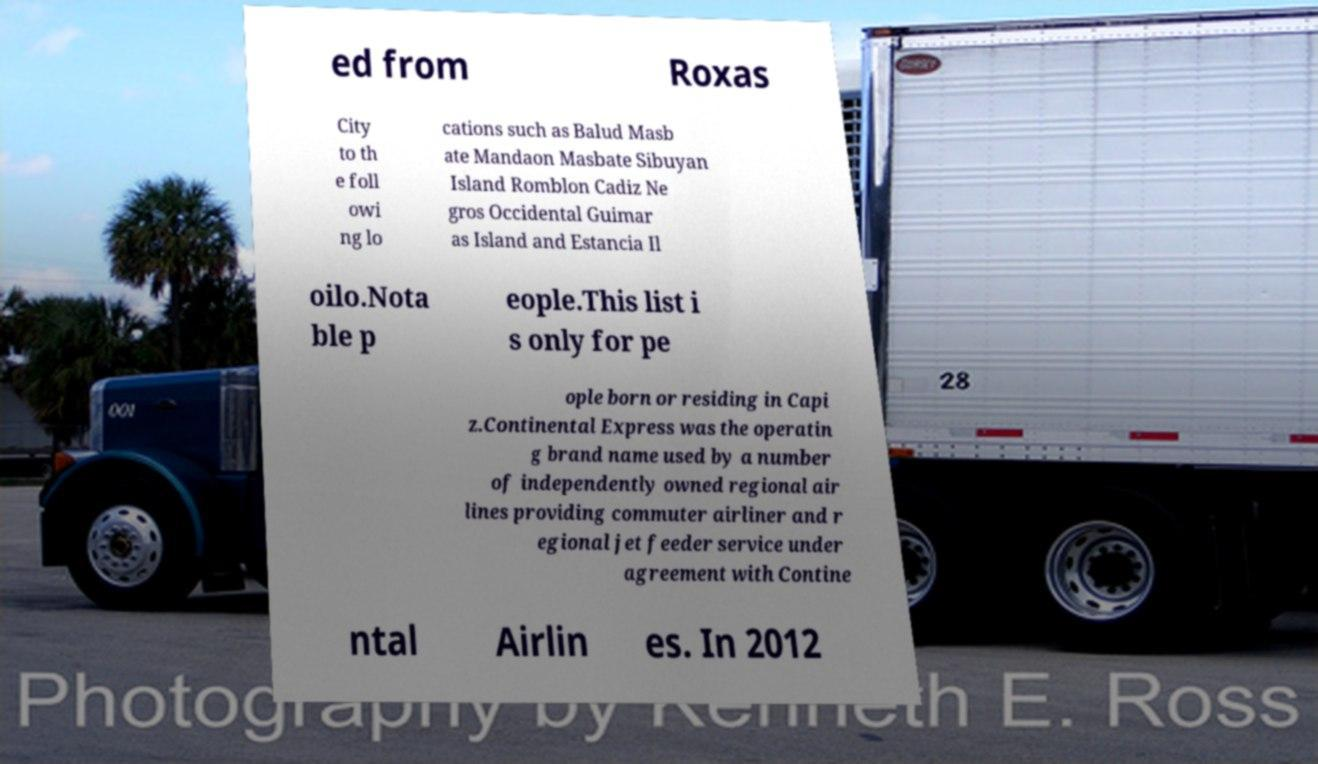What messages or text are displayed in this image? I need them in a readable, typed format. ed from Roxas City to th e foll owi ng lo cations such as Balud Masb ate Mandaon Masbate Sibuyan Island Romblon Cadiz Ne gros Occidental Guimar as Island and Estancia Il oilo.Nota ble p eople.This list i s only for pe ople born or residing in Capi z.Continental Express was the operatin g brand name used by a number of independently owned regional air lines providing commuter airliner and r egional jet feeder service under agreement with Contine ntal Airlin es. In 2012 